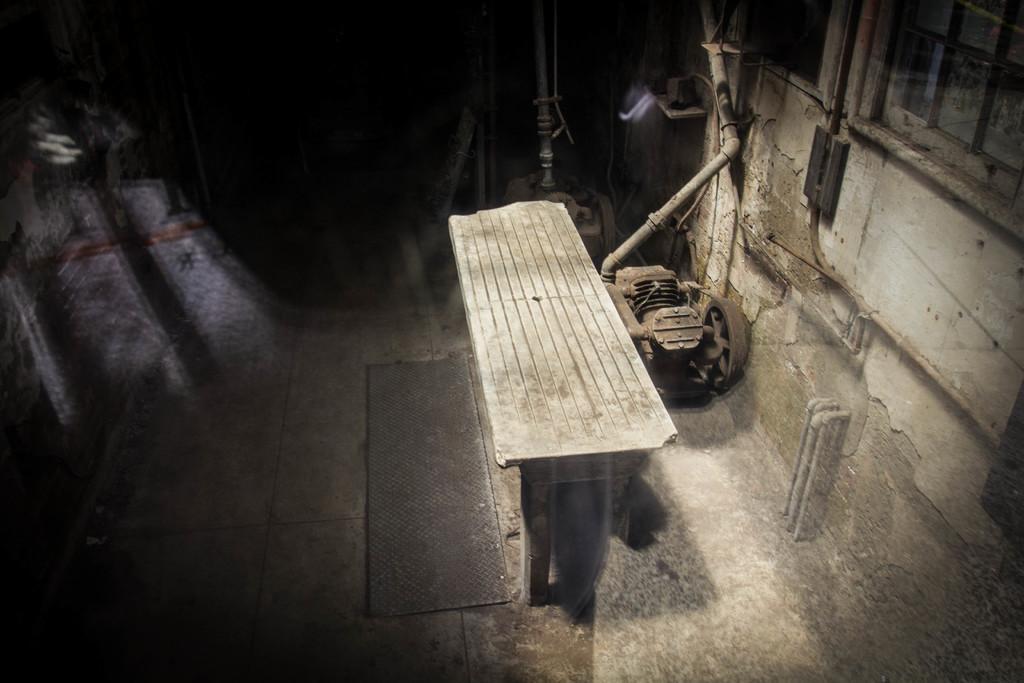Could you give a brief overview of what you see in this image? There is a wooden table in the middle. Beside the table, there is a wall, a pipe, iron item and some other objects. 